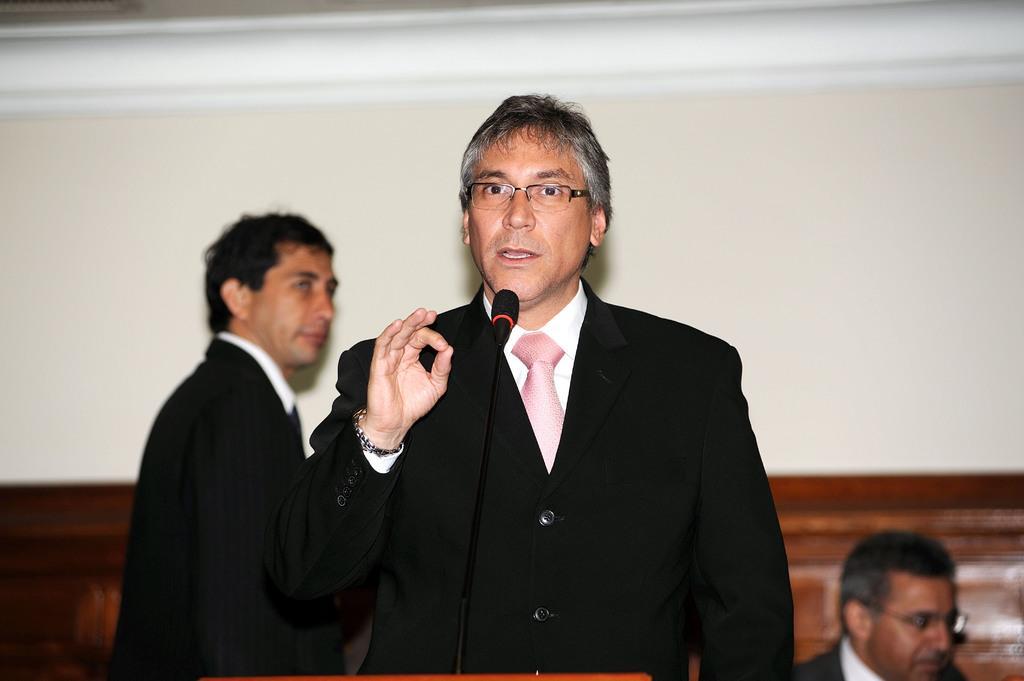Please provide a concise description of this image. In this picture, we can see a few people, microphone and the wall. 